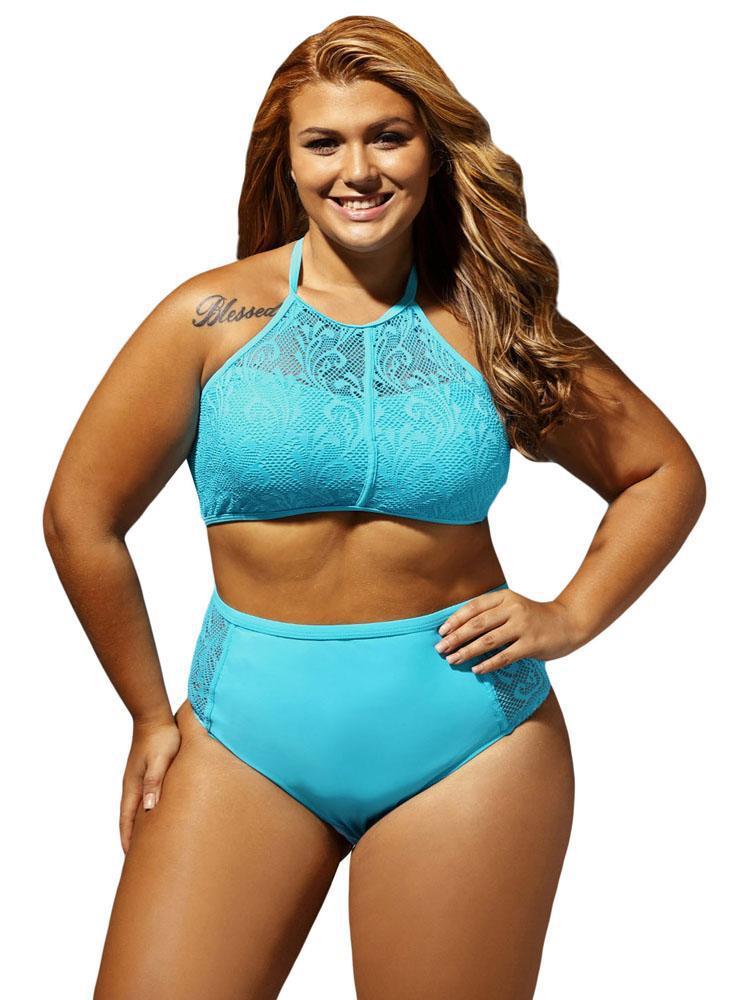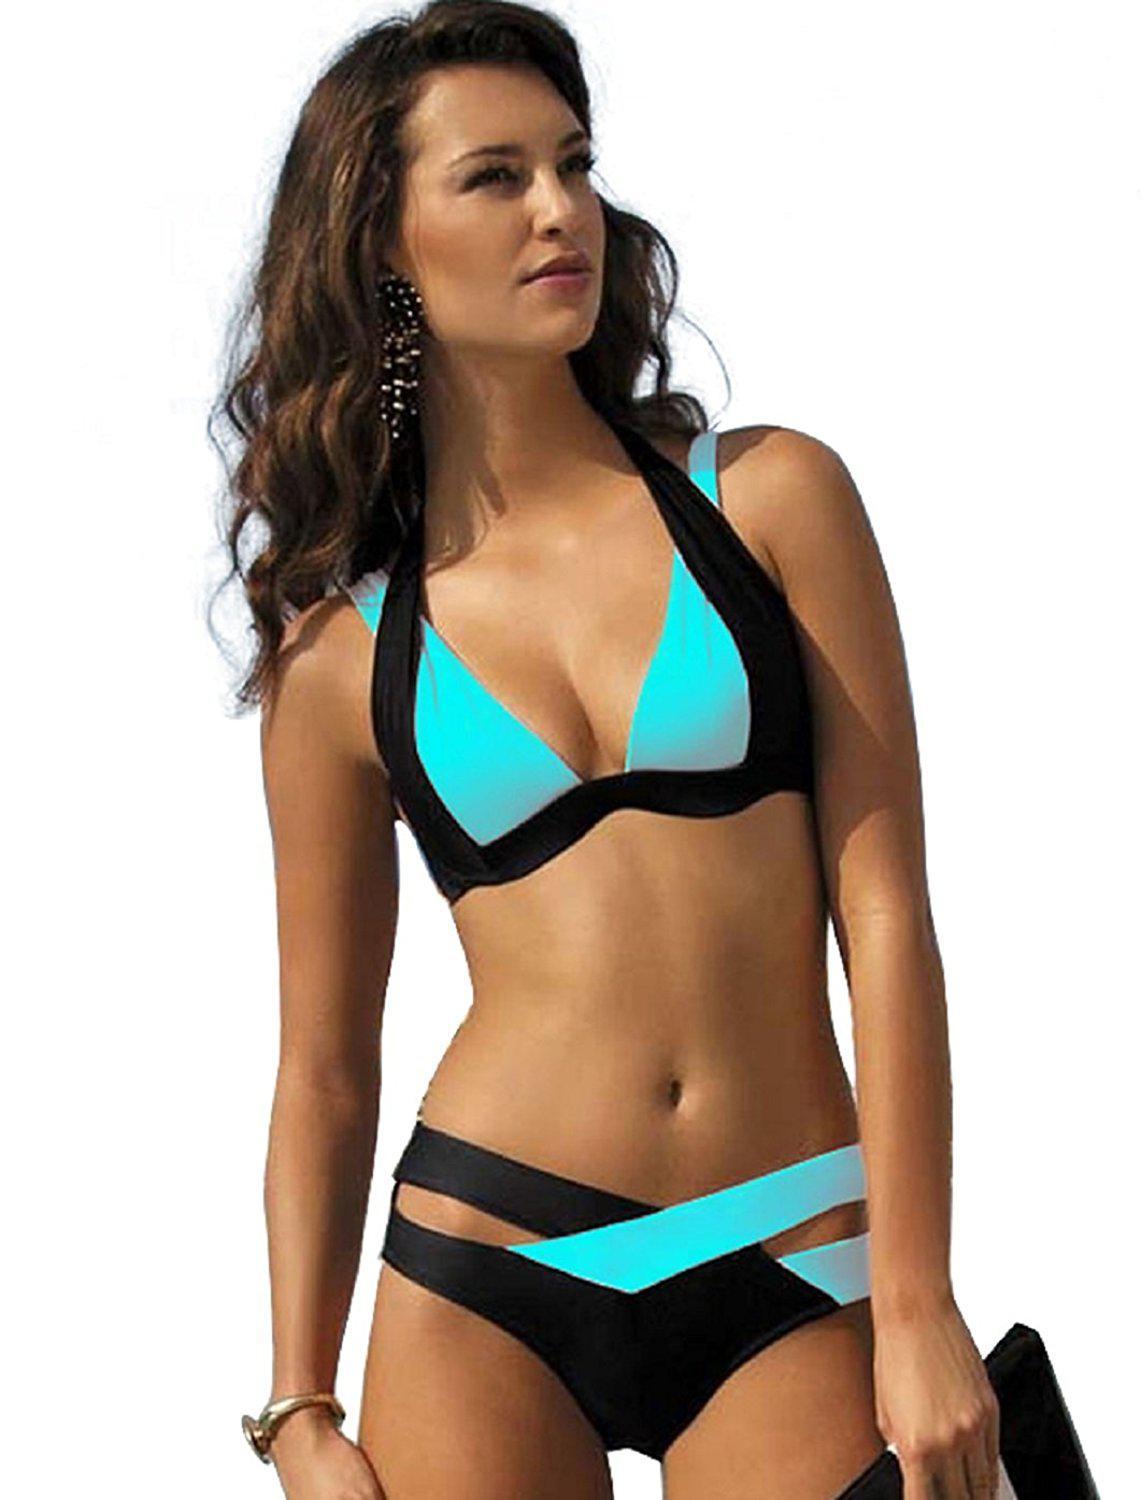The first image is the image on the left, the second image is the image on the right. Analyze the images presented: Is the assertion "There are two bikinis that are primarily blue in color" valid? Answer yes or no. Yes. The first image is the image on the left, the second image is the image on the right. For the images displayed, is the sentence "At least one image features a model in matching-colored solid aqua bikini." factually correct? Answer yes or no. Yes. 